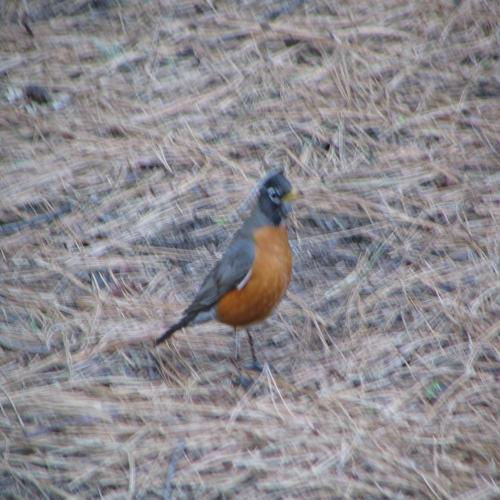Is the main subject of the image a bird on the grass? Yes, the main subject of the image is indeed a bird, which appears to be an American Robin, identifiable by its gray-brown feathers and distinct orange underparts, standing on the grass. 